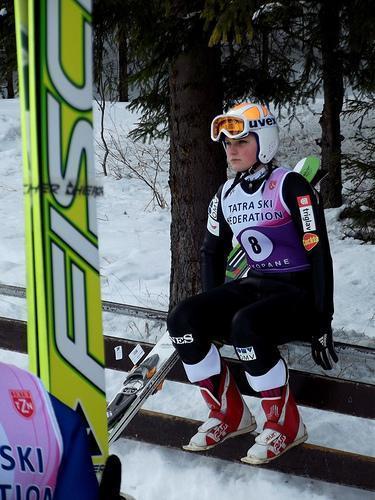How many people are in this photo?
Give a very brief answer. 1. 